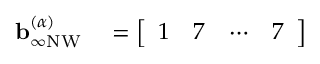<formula> <loc_0><loc_0><loc_500><loc_500>\begin{array} { r l } { b _ { \infty N W } ^ { ( \alpha ) } } & = \left [ \begin{array} { l l l l } { 1 } & { 7 } & { \cdots } & { 7 } \end{array} \right ] } \end{array}</formula> 